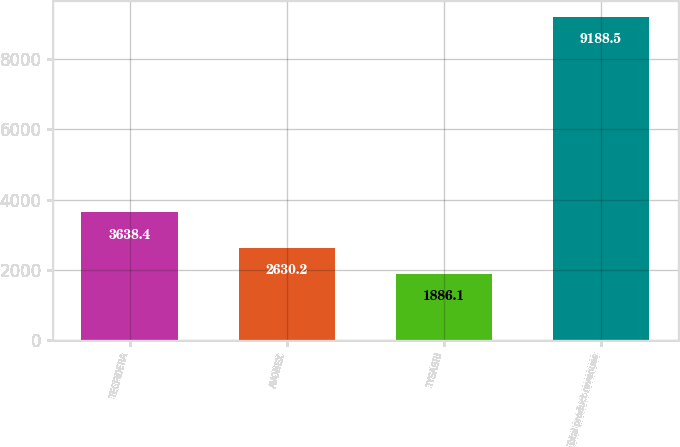<chart> <loc_0><loc_0><loc_500><loc_500><bar_chart><fcel>TECFIDERA<fcel>AVONEX<fcel>TYSABRI<fcel>Total product revenues<nl><fcel>3638.4<fcel>2630.2<fcel>1886.1<fcel>9188.5<nl></chart> 